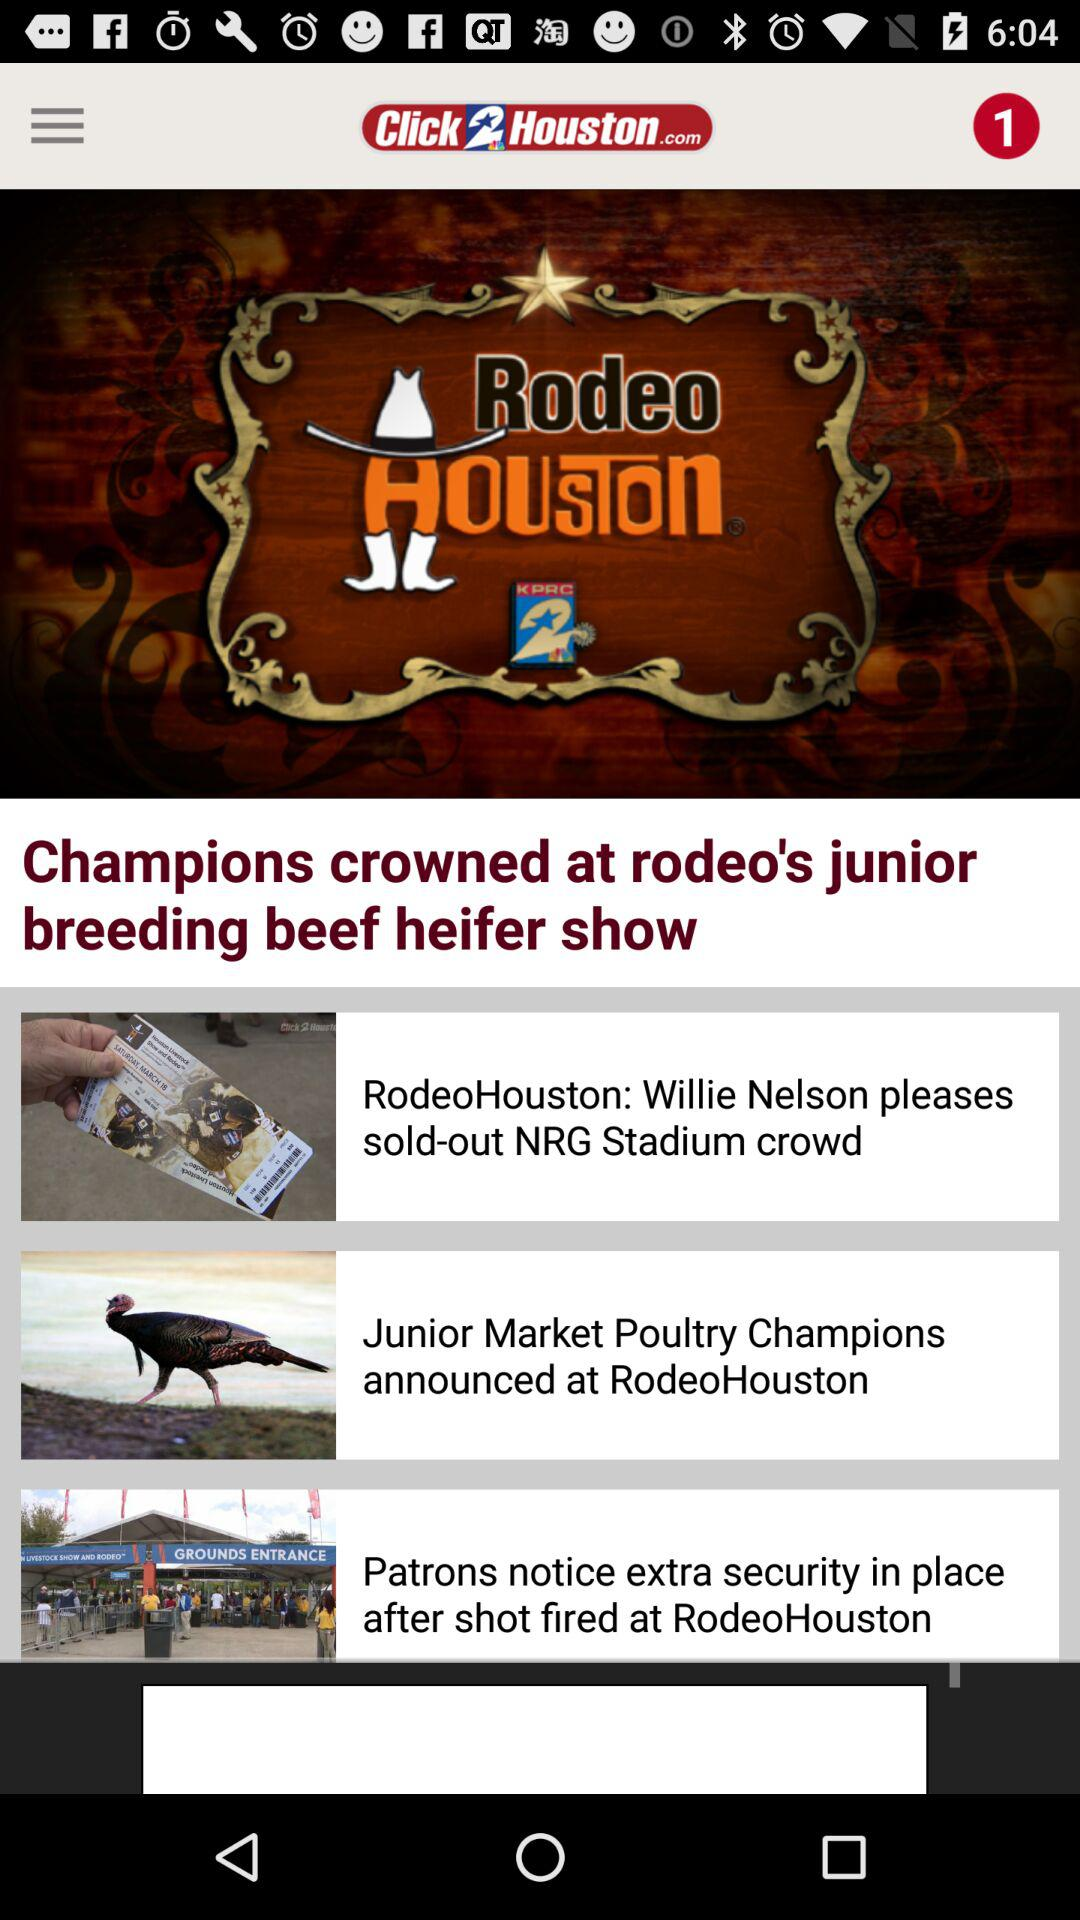What is the headline of the news? The headlines of the news are "Champions crowned at rodeo's junior breeding beef heifer show", "RodeoHouston: Willie Nelson pleases sold-out NRG Stadium crowd", "Junior Market Poultry Champions announced at RodeoHouston" and "Patrons notice extra security in place after shot fired at RodeoHouston". 